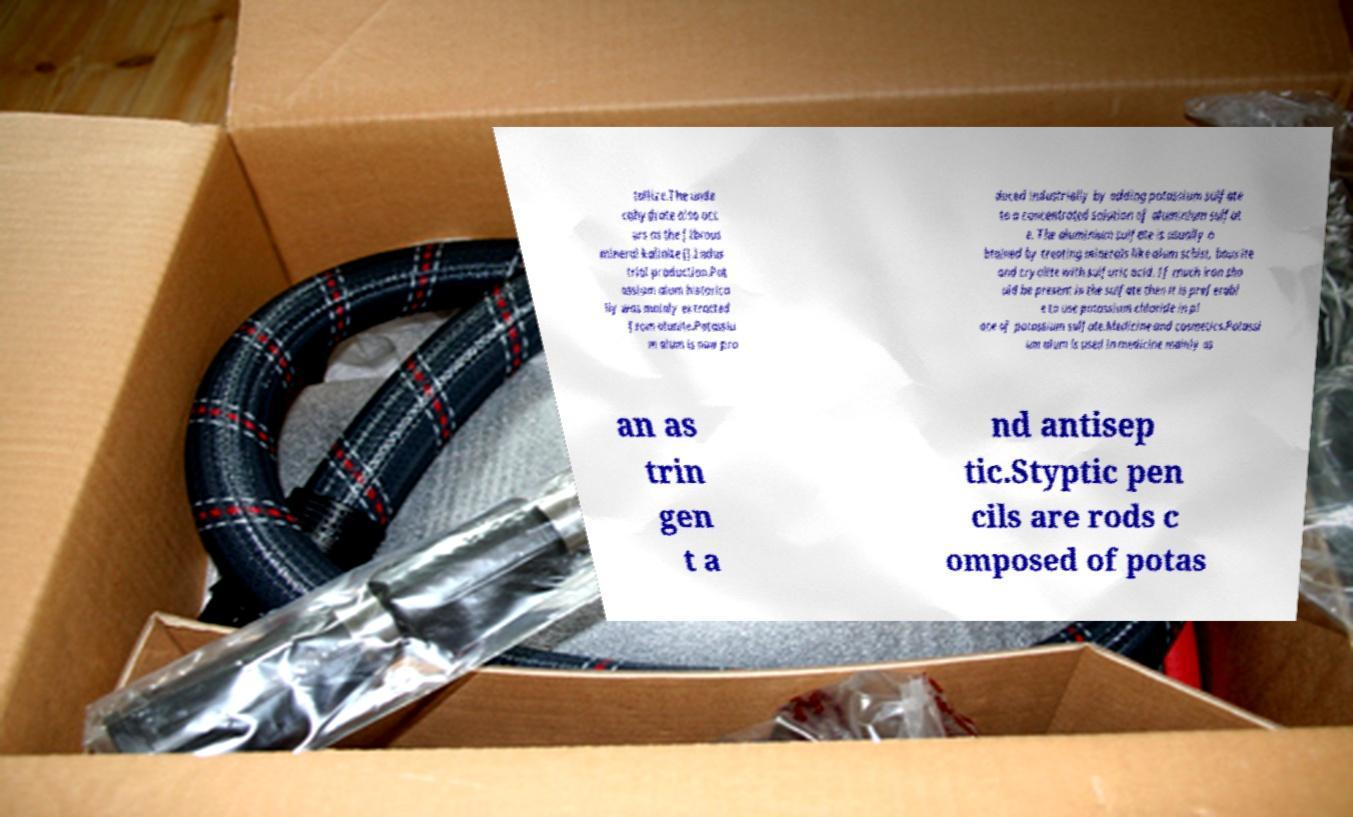Could you assist in decoding the text presented in this image and type it out clearly? tallize.The unde cahydrate also occ urs as the fibrous mineral kalinite ().Indus trial production.Pot assium alum historica lly was mainly extracted from alunite.Potassiu m alum is now pro duced industrially by adding potassium sulfate to a concentrated solution of aluminium sulfat e. The aluminium sulfate is usually o btained by treating minerals like alum schist, bauxite and cryolite with sulfuric acid. If much iron sho uld be present in the sulfate then it is preferabl e to use potassium chloride in pl ace of potassium sulfate.Medicine and cosmetics.Potassi um alum is used in medicine mainly as an as trin gen t a nd antisep tic.Styptic pen cils are rods c omposed of potas 